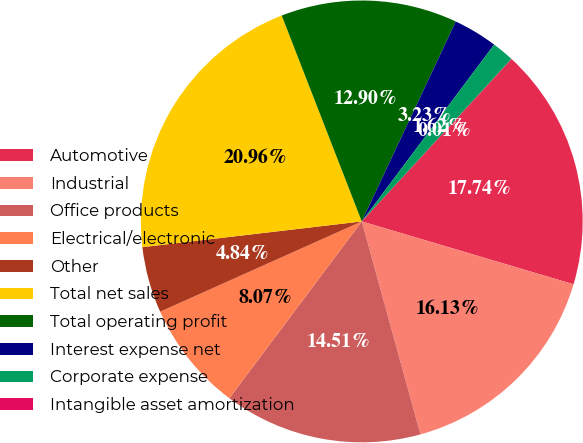Convert chart. <chart><loc_0><loc_0><loc_500><loc_500><pie_chart><fcel>Automotive<fcel>Industrial<fcel>Office products<fcel>Electrical/electronic<fcel>Other<fcel>Total net sales<fcel>Total operating profit<fcel>Interest expense net<fcel>Corporate expense<fcel>Intangible asset amortization<nl><fcel>17.74%<fcel>16.13%<fcel>14.51%<fcel>8.07%<fcel>4.84%<fcel>20.96%<fcel>12.9%<fcel>3.23%<fcel>1.62%<fcel>0.01%<nl></chart> 